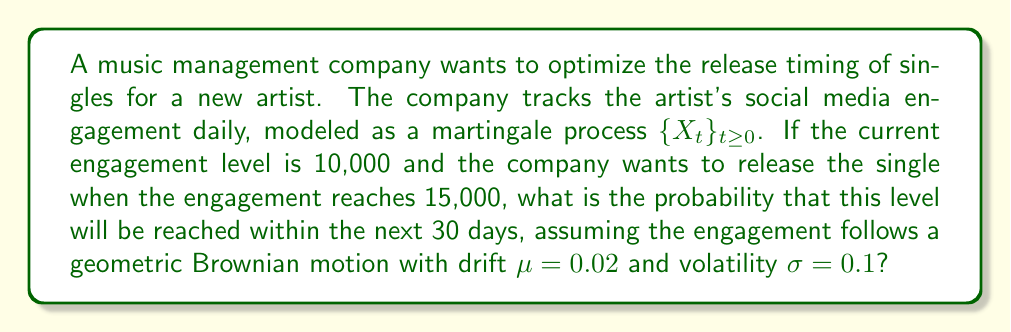Give your solution to this math problem. To solve this problem, we'll use the properties of geometric Brownian motion and the optional sampling theorem for martingales.

Step 1: Identify the relevant parameters
- Initial engagement level: $S_0 = 10,000$
- Target engagement level: $S_T = 15,000$
- Time horizon: $T = 30$ days
- Drift: $\mu = 0.02$
- Volatility: $\sigma = 0.1$

Step 2: Calculate the log-return
The log-return is given by:
$$\ln\left(\frac{S_T}{S_0}\right) = \ln\left(\frac{15,000}{10,000}\right) = \ln(1.5) \approx 0.4055$$

Step 3: Use the properties of geometric Brownian motion
For a geometric Brownian motion, the probability of reaching a certain level by time $T$ is given by:

$$P(S_T \geq 15,000) = N\left(\frac{\ln(S_T/S_0) + (\mu - \frac{1}{2}\sigma^2)T}{\sigma\sqrt{T}}\right)$$

Where $N(\cdot)$ is the cumulative distribution function of the standard normal distribution.

Step 4: Plug in the values
$$P(S_T \geq 15,000) = N\left(\frac{0.4055 + (0.02 - \frac{1}{2}(0.1)^2)30}{0.1\sqrt{30}}\right)$$

Step 5: Simplify
$$P(S_T \geq 15,000) = N\left(\frac{0.4055 + 0.55}{0.5477}\right) = N(1.7433)$$

Step 6: Look up the value in a standard normal table or use a calculator
$$N(1.7433) \approx 0.9594$$

Therefore, the probability of reaching the target engagement level within 30 days is approximately 0.9594 or 95.94%.
Answer: 0.9594 